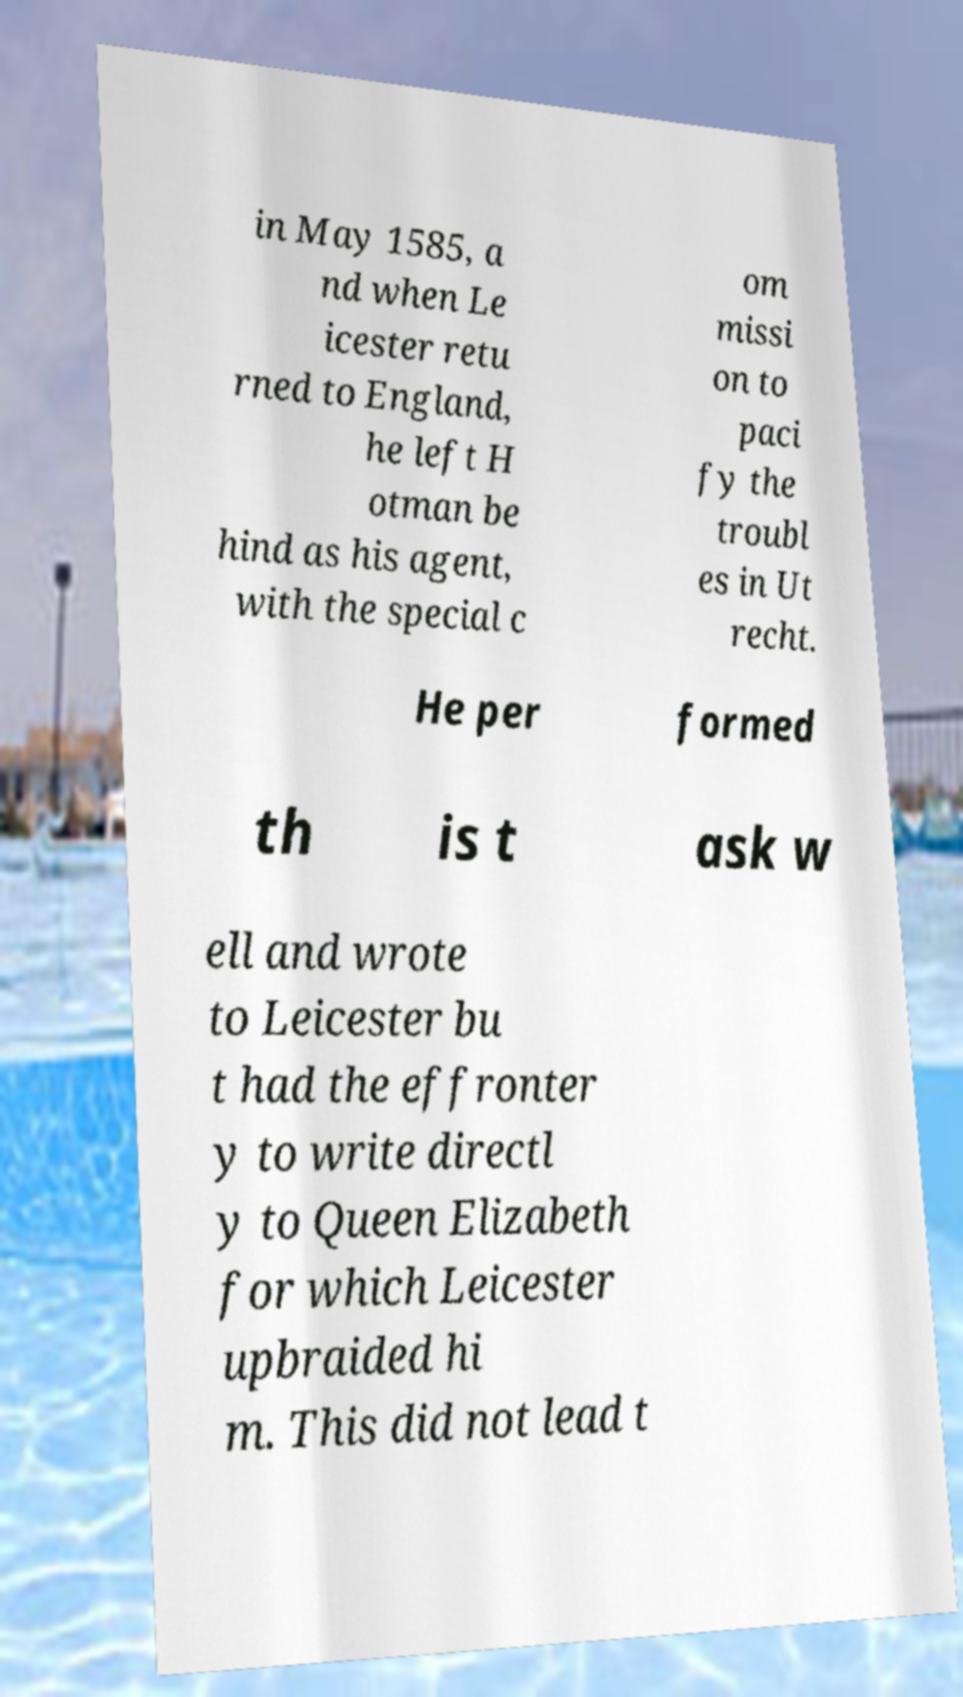Please identify and transcribe the text found in this image. in May 1585, a nd when Le icester retu rned to England, he left H otman be hind as his agent, with the special c om missi on to paci fy the troubl es in Ut recht. He per formed th is t ask w ell and wrote to Leicester bu t had the effronter y to write directl y to Queen Elizabeth for which Leicester upbraided hi m. This did not lead t 